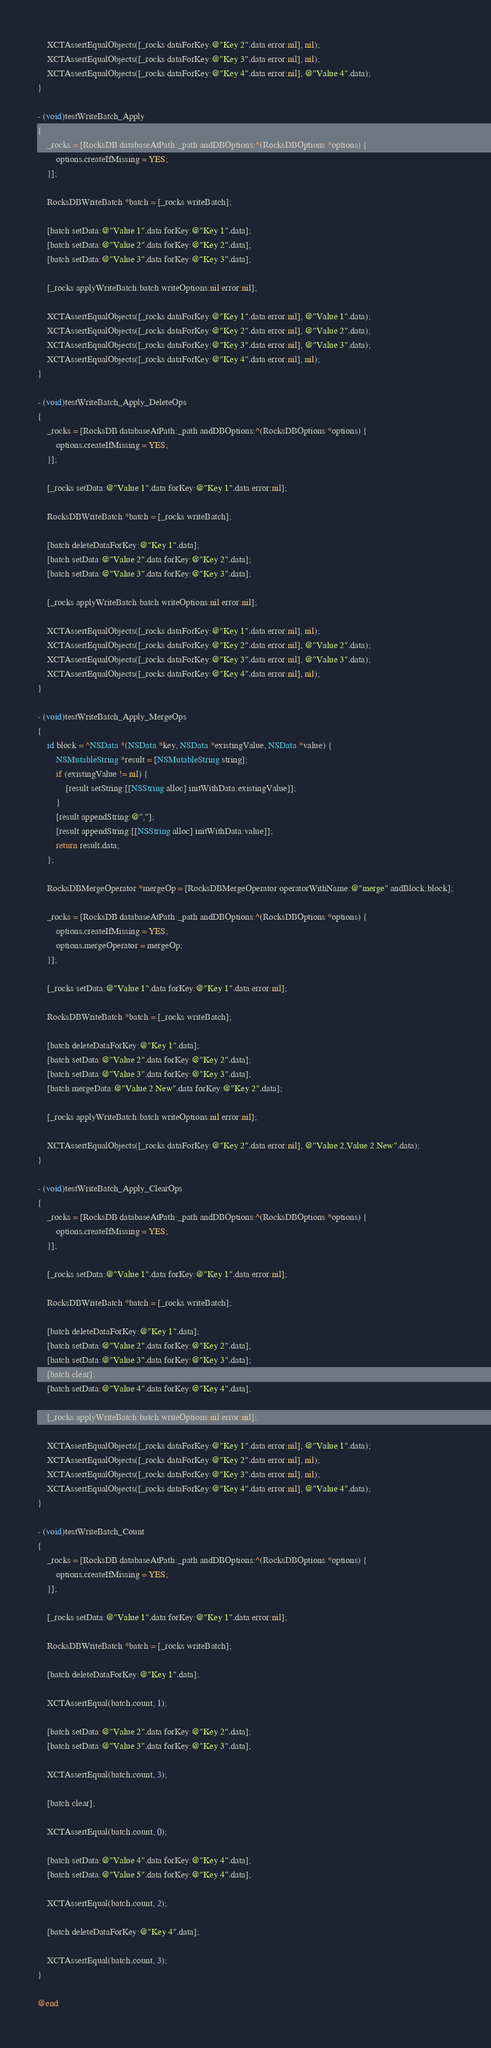Convert code to text. <code><loc_0><loc_0><loc_500><loc_500><_ObjectiveC_>	XCTAssertEqualObjects([_rocks dataForKey:@"Key 2".data error:nil], nil);
	XCTAssertEqualObjects([_rocks dataForKey:@"Key 3".data error:nil], nil);
	XCTAssertEqualObjects([_rocks dataForKey:@"Key 4".data error:nil], @"Value 4".data);
}

- (void)testWriteBatch_Apply
{
	_rocks = [RocksDB databaseAtPath:_path andDBOptions:^(RocksDBOptions *options) {
		options.createIfMissing = YES;
	}];

	RocksDBWriteBatch *batch = [_rocks writeBatch];

	[batch setData:@"Value 1".data forKey:@"Key 1".data];
	[batch setData:@"Value 2".data forKey:@"Key 2".data];
	[batch setData:@"Value 3".data forKey:@"Key 3".data];

	[_rocks applyWriteBatch:batch writeOptions:nil error:nil];

	XCTAssertEqualObjects([_rocks dataForKey:@"Key 1".data error:nil], @"Value 1".data);
	XCTAssertEqualObjects([_rocks dataForKey:@"Key 2".data error:nil], @"Value 2".data);
	XCTAssertEqualObjects([_rocks dataForKey:@"Key 3".data error:nil], @"Value 3".data);
	XCTAssertEqualObjects([_rocks dataForKey:@"Key 4".data error:nil], nil);
}

- (void)testWriteBatch_Apply_DeleteOps
{
	_rocks = [RocksDB databaseAtPath:_path andDBOptions:^(RocksDBOptions *options) {
		options.createIfMissing = YES;
	}];

	[_rocks setData:@"Value 1".data forKey:@"Key 1".data error:nil];

	RocksDBWriteBatch *batch = [_rocks writeBatch];

	[batch deleteDataForKey:@"Key 1".data];
	[batch setData:@"Value 2".data forKey:@"Key 2".data];
	[batch setData:@"Value 3".data forKey:@"Key 3".data];

	[_rocks applyWriteBatch:batch writeOptions:nil error:nil];

	XCTAssertEqualObjects([_rocks dataForKey:@"Key 1".data error:nil], nil);
	XCTAssertEqualObjects([_rocks dataForKey:@"Key 2".data error:nil], @"Value 2".data);
	XCTAssertEqualObjects([_rocks dataForKey:@"Key 3".data error:nil], @"Value 3".data);
	XCTAssertEqualObjects([_rocks dataForKey:@"Key 4".data error:nil], nil);
}

- (void)testWriteBatch_Apply_MergeOps
{
	id block = ^NSData *(NSData *key, NSData *existingValue, NSData *value) {
		NSMutableString *result = [NSMutableString string];
		if (existingValue != nil) {
			[result setString:[[NSString alloc] initWithData:existingValue]];
		}
		[result appendString:@","];
		[result appendString:[[NSString alloc] initWithData:value]];
		return result.data;
	};

	RocksDBMergeOperator *mergeOp = [RocksDBMergeOperator operatorWithName:@"merge" andBlock:block];

	_rocks = [RocksDB databaseAtPath:_path andDBOptions:^(RocksDBOptions *options) {
		options.createIfMissing = YES;
		options.mergeOperator = mergeOp;
	}];

	[_rocks setData:@"Value 1".data forKey:@"Key 1".data error:nil];

	RocksDBWriteBatch *batch = [_rocks writeBatch];

	[batch deleteDataForKey:@"Key 1".data];
	[batch setData:@"Value 2".data forKey:@"Key 2".data];
	[batch setData:@"Value 3".data forKey:@"Key 3".data];
	[batch mergeData:@"Value 2 New".data forKey:@"Key 2".data];

	[_rocks applyWriteBatch:batch writeOptions:nil error:nil];

	XCTAssertEqualObjects([_rocks dataForKey:@"Key 2".data error:nil], @"Value 2,Value 2 New".data);
}

- (void)testWriteBatch_Apply_ClearOps
{
	_rocks = [RocksDB databaseAtPath:_path andDBOptions:^(RocksDBOptions *options) {
		options.createIfMissing = YES;
	}];

	[_rocks setData:@"Value 1".data forKey:@"Key 1".data error:nil];

	RocksDBWriteBatch *batch = [_rocks writeBatch];

	[batch deleteDataForKey:@"Key 1".data];
	[batch setData:@"Value 2".data forKey:@"Key 2".data];
	[batch setData:@"Value 3".data forKey:@"Key 3".data];
	[batch clear];
	[batch setData:@"Value 4".data forKey:@"Key 4".data];

	[_rocks applyWriteBatch:batch writeOptions:nil error:nil];

	XCTAssertEqualObjects([_rocks dataForKey:@"Key 1".data error:nil], @"Value 1".data);
	XCTAssertEqualObjects([_rocks dataForKey:@"Key 2".data error:nil], nil);
	XCTAssertEqualObjects([_rocks dataForKey:@"Key 3".data error:nil], nil);
	XCTAssertEqualObjects([_rocks dataForKey:@"Key 4".data error:nil], @"Value 4".data);
}

- (void)testWriteBatch_Count
{
	_rocks = [RocksDB databaseAtPath:_path andDBOptions:^(RocksDBOptions *options) {
		options.createIfMissing = YES;
	}];

	[_rocks setData:@"Value 1".data forKey:@"Key 1".data error:nil];

	RocksDBWriteBatch *batch = [_rocks writeBatch];

	[batch deleteDataForKey:@"Key 1".data];

	XCTAssertEqual(batch.count, 1);

	[batch setData:@"Value 2".data forKey:@"Key 2".data];
	[batch setData:@"Value 3".data forKey:@"Key 3".data];

	XCTAssertEqual(batch.count, 3);

	[batch clear];

	XCTAssertEqual(batch.count, 0);

	[batch setData:@"Value 4".data forKey:@"Key 4".data];
	[batch setData:@"Value 5".data forKey:@"Key 4".data];

	XCTAssertEqual(batch.count, 2);

	[batch deleteDataForKey:@"Key 4".data];

	XCTAssertEqual(batch.count, 3);
}

@end
</code> 